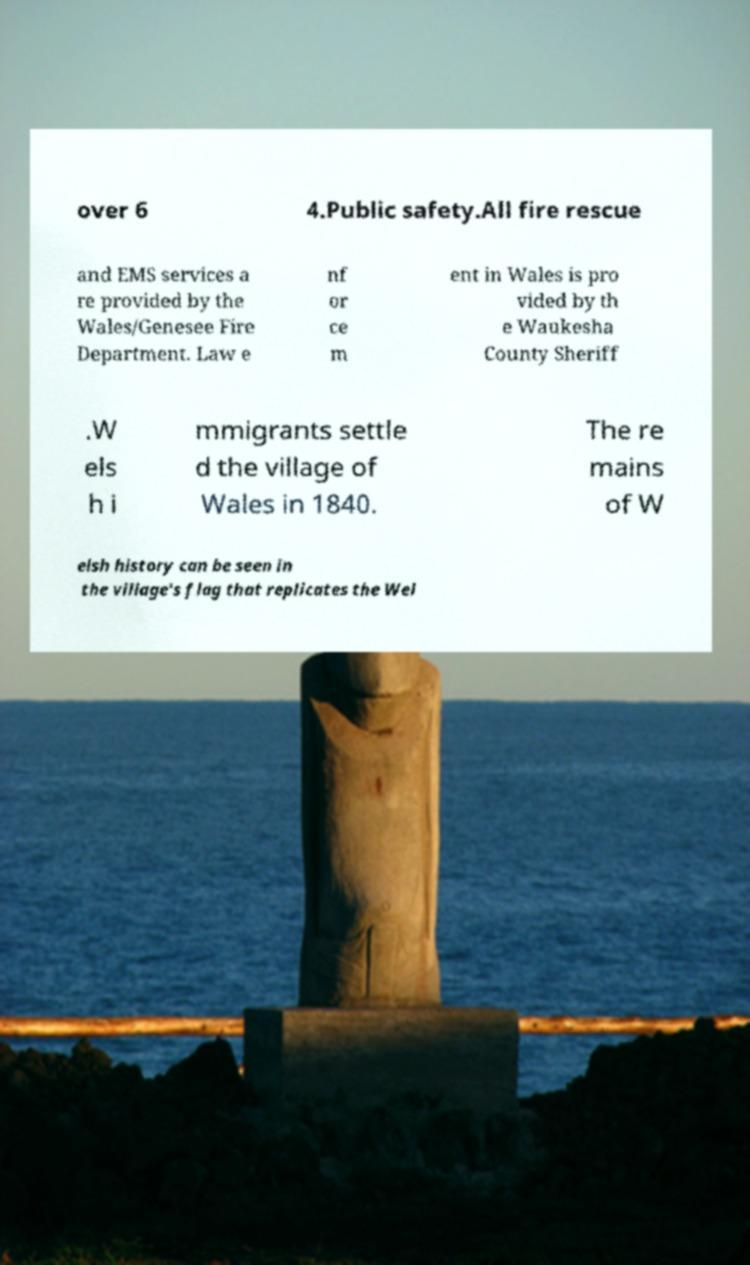Can you read and provide the text displayed in the image?This photo seems to have some interesting text. Can you extract and type it out for me? over 6 4.Public safety.All fire rescue and EMS services a re provided by the Wales/Genesee Fire Department. Law e nf or ce m ent in Wales is pro vided by th e Waukesha County Sheriff .W els h i mmigrants settle d the village of Wales in 1840. The re mains of W elsh history can be seen in the village's flag that replicates the Wel 